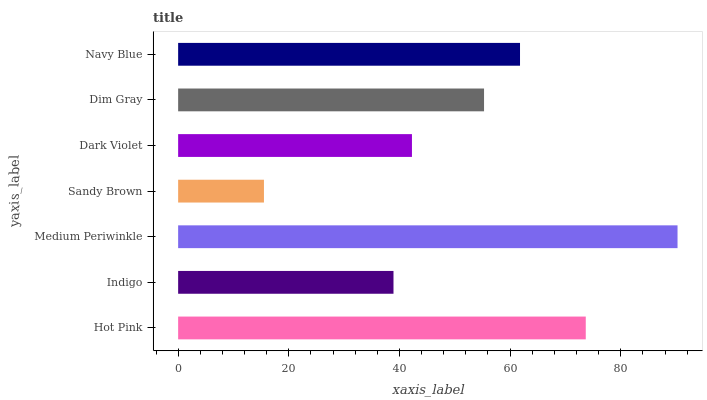Is Sandy Brown the minimum?
Answer yes or no. Yes. Is Medium Periwinkle the maximum?
Answer yes or no. Yes. Is Indigo the minimum?
Answer yes or no. No. Is Indigo the maximum?
Answer yes or no. No. Is Hot Pink greater than Indigo?
Answer yes or no. Yes. Is Indigo less than Hot Pink?
Answer yes or no. Yes. Is Indigo greater than Hot Pink?
Answer yes or no. No. Is Hot Pink less than Indigo?
Answer yes or no. No. Is Dim Gray the high median?
Answer yes or no. Yes. Is Dim Gray the low median?
Answer yes or no. Yes. Is Dark Violet the high median?
Answer yes or no. No. Is Hot Pink the low median?
Answer yes or no. No. 